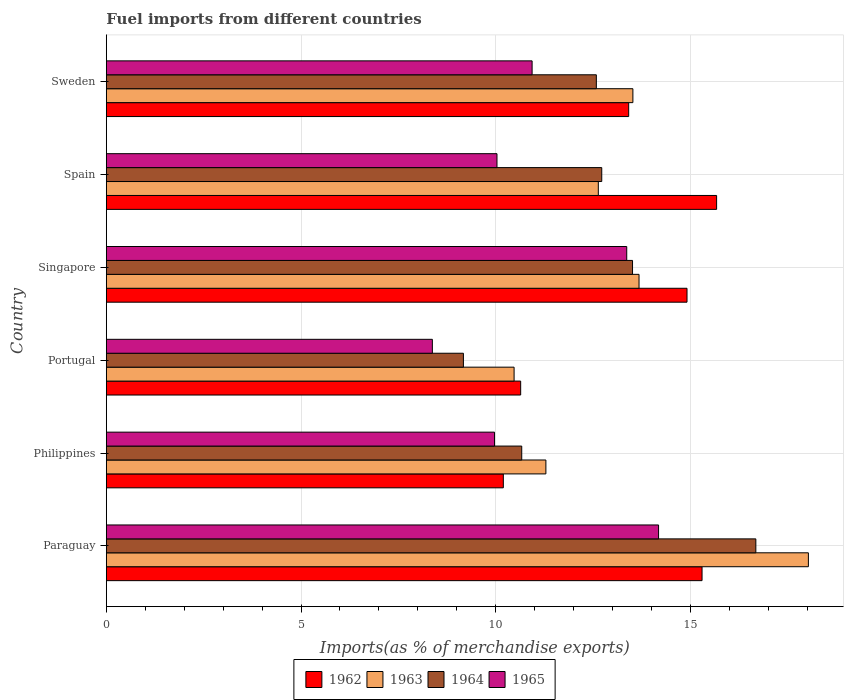How many different coloured bars are there?
Offer a very short reply. 4. How many bars are there on the 4th tick from the bottom?
Provide a succinct answer. 4. What is the label of the 3rd group of bars from the top?
Your answer should be very brief. Singapore. What is the percentage of imports to different countries in 1963 in Paraguay?
Your response must be concise. 18.03. Across all countries, what is the maximum percentage of imports to different countries in 1964?
Offer a terse response. 16.68. Across all countries, what is the minimum percentage of imports to different countries in 1965?
Provide a short and direct response. 8.37. In which country was the percentage of imports to different countries in 1963 maximum?
Provide a succinct answer. Paraguay. In which country was the percentage of imports to different countries in 1963 minimum?
Make the answer very short. Portugal. What is the total percentage of imports to different countries in 1963 in the graph?
Your response must be concise. 79.63. What is the difference between the percentage of imports to different countries in 1964 in Paraguay and that in Singapore?
Provide a short and direct response. 3.17. What is the difference between the percentage of imports to different countries in 1964 in Philippines and the percentage of imports to different countries in 1963 in Spain?
Keep it short and to the point. -1.97. What is the average percentage of imports to different countries in 1965 per country?
Ensure brevity in your answer.  11.14. What is the difference between the percentage of imports to different countries in 1965 and percentage of imports to different countries in 1962 in Sweden?
Make the answer very short. -2.48. In how many countries, is the percentage of imports to different countries in 1964 greater than 2 %?
Your answer should be compact. 6. What is the ratio of the percentage of imports to different countries in 1964 in Spain to that in Sweden?
Make the answer very short. 1.01. What is the difference between the highest and the second highest percentage of imports to different countries in 1964?
Ensure brevity in your answer.  3.17. What is the difference between the highest and the lowest percentage of imports to different countries in 1964?
Make the answer very short. 7.51. In how many countries, is the percentage of imports to different countries in 1963 greater than the average percentage of imports to different countries in 1963 taken over all countries?
Offer a terse response. 3. What does the 4th bar from the top in Sweden represents?
Keep it short and to the point. 1962. What does the 3rd bar from the bottom in Paraguay represents?
Your answer should be very brief. 1964. Are all the bars in the graph horizontal?
Your response must be concise. Yes. What is the difference between two consecutive major ticks on the X-axis?
Keep it short and to the point. 5. Are the values on the major ticks of X-axis written in scientific E-notation?
Provide a short and direct response. No. Does the graph contain grids?
Ensure brevity in your answer.  Yes. Where does the legend appear in the graph?
Offer a very short reply. Bottom center. How many legend labels are there?
Give a very brief answer. 4. How are the legend labels stacked?
Make the answer very short. Horizontal. What is the title of the graph?
Keep it short and to the point. Fuel imports from different countries. What is the label or title of the X-axis?
Your answer should be very brief. Imports(as % of merchandise exports). What is the Imports(as % of merchandise exports) in 1962 in Paraguay?
Offer a very short reply. 15.3. What is the Imports(as % of merchandise exports) of 1963 in Paraguay?
Your answer should be very brief. 18.03. What is the Imports(as % of merchandise exports) of 1964 in Paraguay?
Provide a succinct answer. 16.68. What is the Imports(as % of merchandise exports) in 1965 in Paraguay?
Provide a succinct answer. 14.18. What is the Imports(as % of merchandise exports) of 1962 in Philippines?
Offer a terse response. 10.2. What is the Imports(as % of merchandise exports) in 1963 in Philippines?
Make the answer very short. 11.29. What is the Imports(as % of merchandise exports) in 1964 in Philippines?
Your answer should be very brief. 10.67. What is the Imports(as % of merchandise exports) of 1965 in Philippines?
Ensure brevity in your answer.  9.97. What is the Imports(as % of merchandise exports) in 1962 in Portugal?
Provide a succinct answer. 10.64. What is the Imports(as % of merchandise exports) in 1963 in Portugal?
Your answer should be compact. 10.47. What is the Imports(as % of merchandise exports) in 1964 in Portugal?
Make the answer very short. 9.17. What is the Imports(as % of merchandise exports) in 1965 in Portugal?
Offer a terse response. 8.37. What is the Imports(as % of merchandise exports) of 1962 in Singapore?
Offer a terse response. 14.91. What is the Imports(as % of merchandise exports) in 1963 in Singapore?
Give a very brief answer. 13.68. What is the Imports(as % of merchandise exports) of 1964 in Singapore?
Make the answer very short. 13.51. What is the Imports(as % of merchandise exports) of 1965 in Singapore?
Make the answer very short. 13.37. What is the Imports(as % of merchandise exports) in 1962 in Spain?
Offer a very short reply. 15.67. What is the Imports(as % of merchandise exports) in 1963 in Spain?
Offer a terse response. 12.64. What is the Imports(as % of merchandise exports) of 1964 in Spain?
Offer a terse response. 12.72. What is the Imports(as % of merchandise exports) in 1965 in Spain?
Provide a short and direct response. 10.03. What is the Imports(as % of merchandise exports) of 1962 in Sweden?
Provide a short and direct response. 13.42. What is the Imports(as % of merchandise exports) in 1963 in Sweden?
Provide a short and direct response. 13.52. What is the Imports(as % of merchandise exports) in 1964 in Sweden?
Ensure brevity in your answer.  12.58. What is the Imports(as % of merchandise exports) of 1965 in Sweden?
Your answer should be very brief. 10.93. Across all countries, what is the maximum Imports(as % of merchandise exports) of 1962?
Give a very brief answer. 15.67. Across all countries, what is the maximum Imports(as % of merchandise exports) of 1963?
Your answer should be very brief. 18.03. Across all countries, what is the maximum Imports(as % of merchandise exports) in 1964?
Your answer should be compact. 16.68. Across all countries, what is the maximum Imports(as % of merchandise exports) in 1965?
Your answer should be very brief. 14.18. Across all countries, what is the minimum Imports(as % of merchandise exports) of 1962?
Offer a very short reply. 10.2. Across all countries, what is the minimum Imports(as % of merchandise exports) in 1963?
Keep it short and to the point. 10.47. Across all countries, what is the minimum Imports(as % of merchandise exports) of 1964?
Your response must be concise. 9.17. Across all countries, what is the minimum Imports(as % of merchandise exports) of 1965?
Give a very brief answer. 8.37. What is the total Imports(as % of merchandise exports) in 1962 in the graph?
Ensure brevity in your answer.  80.14. What is the total Imports(as % of merchandise exports) in 1963 in the graph?
Your answer should be very brief. 79.63. What is the total Imports(as % of merchandise exports) in 1964 in the graph?
Make the answer very short. 75.34. What is the total Imports(as % of merchandise exports) of 1965 in the graph?
Offer a terse response. 66.86. What is the difference between the Imports(as % of merchandise exports) of 1962 in Paraguay and that in Philippines?
Your answer should be compact. 5.1. What is the difference between the Imports(as % of merchandise exports) in 1963 in Paraguay and that in Philippines?
Keep it short and to the point. 6.74. What is the difference between the Imports(as % of merchandise exports) of 1964 in Paraguay and that in Philippines?
Make the answer very short. 6.01. What is the difference between the Imports(as % of merchandise exports) in 1965 in Paraguay and that in Philippines?
Your answer should be very brief. 4.21. What is the difference between the Imports(as % of merchandise exports) in 1962 in Paraguay and that in Portugal?
Offer a terse response. 4.66. What is the difference between the Imports(as % of merchandise exports) of 1963 in Paraguay and that in Portugal?
Make the answer very short. 7.56. What is the difference between the Imports(as % of merchandise exports) of 1964 in Paraguay and that in Portugal?
Ensure brevity in your answer.  7.51. What is the difference between the Imports(as % of merchandise exports) of 1965 in Paraguay and that in Portugal?
Your response must be concise. 5.81. What is the difference between the Imports(as % of merchandise exports) of 1962 in Paraguay and that in Singapore?
Give a very brief answer. 0.39. What is the difference between the Imports(as % of merchandise exports) in 1963 in Paraguay and that in Singapore?
Your answer should be very brief. 4.35. What is the difference between the Imports(as % of merchandise exports) of 1964 in Paraguay and that in Singapore?
Offer a terse response. 3.17. What is the difference between the Imports(as % of merchandise exports) of 1965 in Paraguay and that in Singapore?
Your answer should be very brief. 0.82. What is the difference between the Imports(as % of merchandise exports) in 1962 in Paraguay and that in Spain?
Ensure brevity in your answer.  -0.37. What is the difference between the Imports(as % of merchandise exports) in 1963 in Paraguay and that in Spain?
Offer a very short reply. 5.4. What is the difference between the Imports(as % of merchandise exports) in 1964 in Paraguay and that in Spain?
Provide a succinct answer. 3.96. What is the difference between the Imports(as % of merchandise exports) of 1965 in Paraguay and that in Spain?
Keep it short and to the point. 4.15. What is the difference between the Imports(as % of merchandise exports) in 1962 in Paraguay and that in Sweden?
Ensure brevity in your answer.  1.88. What is the difference between the Imports(as % of merchandise exports) in 1963 in Paraguay and that in Sweden?
Your response must be concise. 4.51. What is the difference between the Imports(as % of merchandise exports) of 1964 in Paraguay and that in Sweden?
Make the answer very short. 4.1. What is the difference between the Imports(as % of merchandise exports) in 1965 in Paraguay and that in Sweden?
Make the answer very short. 3.25. What is the difference between the Imports(as % of merchandise exports) in 1962 in Philippines and that in Portugal?
Your response must be concise. -0.45. What is the difference between the Imports(as % of merchandise exports) in 1963 in Philippines and that in Portugal?
Your answer should be compact. 0.82. What is the difference between the Imports(as % of merchandise exports) in 1964 in Philippines and that in Portugal?
Ensure brevity in your answer.  1.5. What is the difference between the Imports(as % of merchandise exports) of 1965 in Philippines and that in Portugal?
Offer a terse response. 1.6. What is the difference between the Imports(as % of merchandise exports) of 1962 in Philippines and that in Singapore?
Give a very brief answer. -4.72. What is the difference between the Imports(as % of merchandise exports) of 1963 in Philippines and that in Singapore?
Your answer should be very brief. -2.39. What is the difference between the Imports(as % of merchandise exports) of 1964 in Philippines and that in Singapore?
Provide a short and direct response. -2.85. What is the difference between the Imports(as % of merchandise exports) in 1965 in Philippines and that in Singapore?
Make the answer very short. -3.4. What is the difference between the Imports(as % of merchandise exports) in 1962 in Philippines and that in Spain?
Your answer should be compact. -5.48. What is the difference between the Imports(as % of merchandise exports) of 1963 in Philippines and that in Spain?
Provide a short and direct response. -1.35. What is the difference between the Imports(as % of merchandise exports) of 1964 in Philippines and that in Spain?
Ensure brevity in your answer.  -2.05. What is the difference between the Imports(as % of merchandise exports) of 1965 in Philippines and that in Spain?
Make the answer very short. -0.06. What is the difference between the Imports(as % of merchandise exports) in 1962 in Philippines and that in Sweden?
Your answer should be compact. -3.22. What is the difference between the Imports(as % of merchandise exports) of 1963 in Philippines and that in Sweden?
Give a very brief answer. -2.23. What is the difference between the Imports(as % of merchandise exports) of 1964 in Philippines and that in Sweden?
Provide a succinct answer. -1.92. What is the difference between the Imports(as % of merchandise exports) of 1965 in Philippines and that in Sweden?
Keep it short and to the point. -0.96. What is the difference between the Imports(as % of merchandise exports) of 1962 in Portugal and that in Singapore?
Keep it short and to the point. -4.27. What is the difference between the Imports(as % of merchandise exports) of 1963 in Portugal and that in Singapore?
Make the answer very short. -3.21. What is the difference between the Imports(as % of merchandise exports) of 1964 in Portugal and that in Singapore?
Your response must be concise. -4.34. What is the difference between the Imports(as % of merchandise exports) of 1965 in Portugal and that in Singapore?
Provide a succinct answer. -4.99. What is the difference between the Imports(as % of merchandise exports) in 1962 in Portugal and that in Spain?
Ensure brevity in your answer.  -5.03. What is the difference between the Imports(as % of merchandise exports) in 1963 in Portugal and that in Spain?
Offer a very short reply. -2.16. What is the difference between the Imports(as % of merchandise exports) of 1964 in Portugal and that in Spain?
Ensure brevity in your answer.  -3.55. What is the difference between the Imports(as % of merchandise exports) in 1965 in Portugal and that in Spain?
Provide a succinct answer. -1.66. What is the difference between the Imports(as % of merchandise exports) in 1962 in Portugal and that in Sweden?
Provide a short and direct response. -2.77. What is the difference between the Imports(as % of merchandise exports) in 1963 in Portugal and that in Sweden?
Ensure brevity in your answer.  -3.05. What is the difference between the Imports(as % of merchandise exports) of 1964 in Portugal and that in Sweden?
Provide a short and direct response. -3.41. What is the difference between the Imports(as % of merchandise exports) of 1965 in Portugal and that in Sweden?
Provide a succinct answer. -2.56. What is the difference between the Imports(as % of merchandise exports) of 1962 in Singapore and that in Spain?
Provide a short and direct response. -0.76. What is the difference between the Imports(as % of merchandise exports) in 1963 in Singapore and that in Spain?
Offer a terse response. 1.05. What is the difference between the Imports(as % of merchandise exports) in 1964 in Singapore and that in Spain?
Your answer should be compact. 0.79. What is the difference between the Imports(as % of merchandise exports) in 1965 in Singapore and that in Spain?
Your response must be concise. 3.33. What is the difference between the Imports(as % of merchandise exports) in 1962 in Singapore and that in Sweden?
Make the answer very short. 1.5. What is the difference between the Imports(as % of merchandise exports) of 1963 in Singapore and that in Sweden?
Your response must be concise. 0.16. What is the difference between the Imports(as % of merchandise exports) in 1964 in Singapore and that in Sweden?
Offer a very short reply. 0.93. What is the difference between the Imports(as % of merchandise exports) in 1965 in Singapore and that in Sweden?
Your answer should be compact. 2.43. What is the difference between the Imports(as % of merchandise exports) in 1962 in Spain and that in Sweden?
Ensure brevity in your answer.  2.26. What is the difference between the Imports(as % of merchandise exports) in 1963 in Spain and that in Sweden?
Your answer should be compact. -0.89. What is the difference between the Imports(as % of merchandise exports) of 1964 in Spain and that in Sweden?
Keep it short and to the point. 0.14. What is the difference between the Imports(as % of merchandise exports) in 1965 in Spain and that in Sweden?
Ensure brevity in your answer.  -0.9. What is the difference between the Imports(as % of merchandise exports) in 1962 in Paraguay and the Imports(as % of merchandise exports) in 1963 in Philippines?
Your answer should be compact. 4.01. What is the difference between the Imports(as % of merchandise exports) of 1962 in Paraguay and the Imports(as % of merchandise exports) of 1964 in Philippines?
Offer a terse response. 4.63. What is the difference between the Imports(as % of merchandise exports) of 1962 in Paraguay and the Imports(as % of merchandise exports) of 1965 in Philippines?
Ensure brevity in your answer.  5.33. What is the difference between the Imports(as % of merchandise exports) in 1963 in Paraguay and the Imports(as % of merchandise exports) in 1964 in Philippines?
Offer a terse response. 7.36. What is the difference between the Imports(as % of merchandise exports) of 1963 in Paraguay and the Imports(as % of merchandise exports) of 1965 in Philippines?
Offer a very short reply. 8.06. What is the difference between the Imports(as % of merchandise exports) in 1964 in Paraguay and the Imports(as % of merchandise exports) in 1965 in Philippines?
Give a very brief answer. 6.71. What is the difference between the Imports(as % of merchandise exports) of 1962 in Paraguay and the Imports(as % of merchandise exports) of 1963 in Portugal?
Offer a terse response. 4.83. What is the difference between the Imports(as % of merchandise exports) in 1962 in Paraguay and the Imports(as % of merchandise exports) in 1964 in Portugal?
Offer a very short reply. 6.13. What is the difference between the Imports(as % of merchandise exports) of 1962 in Paraguay and the Imports(as % of merchandise exports) of 1965 in Portugal?
Provide a succinct answer. 6.93. What is the difference between the Imports(as % of merchandise exports) in 1963 in Paraguay and the Imports(as % of merchandise exports) in 1964 in Portugal?
Give a very brief answer. 8.86. What is the difference between the Imports(as % of merchandise exports) in 1963 in Paraguay and the Imports(as % of merchandise exports) in 1965 in Portugal?
Keep it short and to the point. 9.66. What is the difference between the Imports(as % of merchandise exports) of 1964 in Paraguay and the Imports(as % of merchandise exports) of 1965 in Portugal?
Make the answer very short. 8.31. What is the difference between the Imports(as % of merchandise exports) in 1962 in Paraguay and the Imports(as % of merchandise exports) in 1963 in Singapore?
Provide a succinct answer. 1.62. What is the difference between the Imports(as % of merchandise exports) in 1962 in Paraguay and the Imports(as % of merchandise exports) in 1964 in Singapore?
Offer a terse response. 1.79. What is the difference between the Imports(as % of merchandise exports) in 1962 in Paraguay and the Imports(as % of merchandise exports) in 1965 in Singapore?
Provide a succinct answer. 1.93. What is the difference between the Imports(as % of merchandise exports) in 1963 in Paraguay and the Imports(as % of merchandise exports) in 1964 in Singapore?
Provide a succinct answer. 4.52. What is the difference between the Imports(as % of merchandise exports) of 1963 in Paraguay and the Imports(as % of merchandise exports) of 1965 in Singapore?
Your answer should be compact. 4.67. What is the difference between the Imports(as % of merchandise exports) of 1964 in Paraguay and the Imports(as % of merchandise exports) of 1965 in Singapore?
Make the answer very short. 3.32. What is the difference between the Imports(as % of merchandise exports) of 1962 in Paraguay and the Imports(as % of merchandise exports) of 1963 in Spain?
Keep it short and to the point. 2.66. What is the difference between the Imports(as % of merchandise exports) in 1962 in Paraguay and the Imports(as % of merchandise exports) in 1964 in Spain?
Give a very brief answer. 2.58. What is the difference between the Imports(as % of merchandise exports) of 1962 in Paraguay and the Imports(as % of merchandise exports) of 1965 in Spain?
Your response must be concise. 5.27. What is the difference between the Imports(as % of merchandise exports) in 1963 in Paraguay and the Imports(as % of merchandise exports) in 1964 in Spain?
Ensure brevity in your answer.  5.31. What is the difference between the Imports(as % of merchandise exports) in 1963 in Paraguay and the Imports(as % of merchandise exports) in 1965 in Spain?
Provide a succinct answer. 8. What is the difference between the Imports(as % of merchandise exports) of 1964 in Paraguay and the Imports(as % of merchandise exports) of 1965 in Spain?
Offer a terse response. 6.65. What is the difference between the Imports(as % of merchandise exports) of 1962 in Paraguay and the Imports(as % of merchandise exports) of 1963 in Sweden?
Ensure brevity in your answer.  1.78. What is the difference between the Imports(as % of merchandise exports) of 1962 in Paraguay and the Imports(as % of merchandise exports) of 1964 in Sweden?
Keep it short and to the point. 2.71. What is the difference between the Imports(as % of merchandise exports) of 1962 in Paraguay and the Imports(as % of merchandise exports) of 1965 in Sweden?
Your response must be concise. 4.36. What is the difference between the Imports(as % of merchandise exports) of 1963 in Paraguay and the Imports(as % of merchandise exports) of 1964 in Sweden?
Offer a very short reply. 5.45. What is the difference between the Imports(as % of merchandise exports) of 1963 in Paraguay and the Imports(as % of merchandise exports) of 1965 in Sweden?
Your answer should be very brief. 7.1. What is the difference between the Imports(as % of merchandise exports) in 1964 in Paraguay and the Imports(as % of merchandise exports) in 1965 in Sweden?
Provide a short and direct response. 5.75. What is the difference between the Imports(as % of merchandise exports) of 1962 in Philippines and the Imports(as % of merchandise exports) of 1963 in Portugal?
Offer a terse response. -0.28. What is the difference between the Imports(as % of merchandise exports) of 1962 in Philippines and the Imports(as % of merchandise exports) of 1964 in Portugal?
Your response must be concise. 1.03. What is the difference between the Imports(as % of merchandise exports) in 1962 in Philippines and the Imports(as % of merchandise exports) in 1965 in Portugal?
Give a very brief answer. 1.82. What is the difference between the Imports(as % of merchandise exports) of 1963 in Philippines and the Imports(as % of merchandise exports) of 1964 in Portugal?
Offer a very short reply. 2.12. What is the difference between the Imports(as % of merchandise exports) of 1963 in Philippines and the Imports(as % of merchandise exports) of 1965 in Portugal?
Provide a succinct answer. 2.92. What is the difference between the Imports(as % of merchandise exports) of 1964 in Philippines and the Imports(as % of merchandise exports) of 1965 in Portugal?
Provide a short and direct response. 2.3. What is the difference between the Imports(as % of merchandise exports) in 1962 in Philippines and the Imports(as % of merchandise exports) in 1963 in Singapore?
Provide a succinct answer. -3.49. What is the difference between the Imports(as % of merchandise exports) of 1962 in Philippines and the Imports(as % of merchandise exports) of 1964 in Singapore?
Keep it short and to the point. -3.32. What is the difference between the Imports(as % of merchandise exports) in 1962 in Philippines and the Imports(as % of merchandise exports) in 1965 in Singapore?
Provide a short and direct response. -3.17. What is the difference between the Imports(as % of merchandise exports) in 1963 in Philippines and the Imports(as % of merchandise exports) in 1964 in Singapore?
Give a very brief answer. -2.23. What is the difference between the Imports(as % of merchandise exports) of 1963 in Philippines and the Imports(as % of merchandise exports) of 1965 in Singapore?
Provide a short and direct response. -2.08. What is the difference between the Imports(as % of merchandise exports) in 1964 in Philippines and the Imports(as % of merchandise exports) in 1965 in Singapore?
Offer a very short reply. -2.7. What is the difference between the Imports(as % of merchandise exports) of 1962 in Philippines and the Imports(as % of merchandise exports) of 1963 in Spain?
Offer a terse response. -2.44. What is the difference between the Imports(as % of merchandise exports) in 1962 in Philippines and the Imports(as % of merchandise exports) in 1964 in Spain?
Keep it short and to the point. -2.53. What is the difference between the Imports(as % of merchandise exports) of 1962 in Philippines and the Imports(as % of merchandise exports) of 1965 in Spain?
Offer a very short reply. 0.16. What is the difference between the Imports(as % of merchandise exports) in 1963 in Philippines and the Imports(as % of merchandise exports) in 1964 in Spain?
Provide a succinct answer. -1.43. What is the difference between the Imports(as % of merchandise exports) in 1963 in Philippines and the Imports(as % of merchandise exports) in 1965 in Spain?
Provide a short and direct response. 1.26. What is the difference between the Imports(as % of merchandise exports) of 1964 in Philippines and the Imports(as % of merchandise exports) of 1965 in Spain?
Make the answer very short. 0.64. What is the difference between the Imports(as % of merchandise exports) in 1962 in Philippines and the Imports(as % of merchandise exports) in 1963 in Sweden?
Ensure brevity in your answer.  -3.33. What is the difference between the Imports(as % of merchandise exports) in 1962 in Philippines and the Imports(as % of merchandise exports) in 1964 in Sweden?
Offer a very short reply. -2.39. What is the difference between the Imports(as % of merchandise exports) of 1962 in Philippines and the Imports(as % of merchandise exports) of 1965 in Sweden?
Make the answer very short. -0.74. What is the difference between the Imports(as % of merchandise exports) of 1963 in Philippines and the Imports(as % of merchandise exports) of 1964 in Sweden?
Your answer should be compact. -1.3. What is the difference between the Imports(as % of merchandise exports) of 1963 in Philippines and the Imports(as % of merchandise exports) of 1965 in Sweden?
Keep it short and to the point. 0.35. What is the difference between the Imports(as % of merchandise exports) of 1964 in Philippines and the Imports(as % of merchandise exports) of 1965 in Sweden?
Offer a very short reply. -0.27. What is the difference between the Imports(as % of merchandise exports) of 1962 in Portugal and the Imports(as % of merchandise exports) of 1963 in Singapore?
Offer a terse response. -3.04. What is the difference between the Imports(as % of merchandise exports) in 1962 in Portugal and the Imports(as % of merchandise exports) in 1964 in Singapore?
Provide a succinct answer. -2.87. What is the difference between the Imports(as % of merchandise exports) in 1962 in Portugal and the Imports(as % of merchandise exports) in 1965 in Singapore?
Offer a terse response. -2.72. What is the difference between the Imports(as % of merchandise exports) of 1963 in Portugal and the Imports(as % of merchandise exports) of 1964 in Singapore?
Provide a succinct answer. -3.04. What is the difference between the Imports(as % of merchandise exports) in 1963 in Portugal and the Imports(as % of merchandise exports) in 1965 in Singapore?
Keep it short and to the point. -2.89. What is the difference between the Imports(as % of merchandise exports) of 1964 in Portugal and the Imports(as % of merchandise exports) of 1965 in Singapore?
Give a very brief answer. -4.19. What is the difference between the Imports(as % of merchandise exports) in 1962 in Portugal and the Imports(as % of merchandise exports) in 1963 in Spain?
Your response must be concise. -1.99. What is the difference between the Imports(as % of merchandise exports) in 1962 in Portugal and the Imports(as % of merchandise exports) in 1964 in Spain?
Offer a very short reply. -2.08. What is the difference between the Imports(as % of merchandise exports) in 1962 in Portugal and the Imports(as % of merchandise exports) in 1965 in Spain?
Provide a short and direct response. 0.61. What is the difference between the Imports(as % of merchandise exports) of 1963 in Portugal and the Imports(as % of merchandise exports) of 1964 in Spain?
Make the answer very short. -2.25. What is the difference between the Imports(as % of merchandise exports) of 1963 in Portugal and the Imports(as % of merchandise exports) of 1965 in Spain?
Provide a short and direct response. 0.44. What is the difference between the Imports(as % of merchandise exports) in 1964 in Portugal and the Imports(as % of merchandise exports) in 1965 in Spain?
Make the answer very short. -0.86. What is the difference between the Imports(as % of merchandise exports) of 1962 in Portugal and the Imports(as % of merchandise exports) of 1963 in Sweden?
Give a very brief answer. -2.88. What is the difference between the Imports(as % of merchandise exports) in 1962 in Portugal and the Imports(as % of merchandise exports) in 1964 in Sweden?
Ensure brevity in your answer.  -1.94. What is the difference between the Imports(as % of merchandise exports) in 1962 in Portugal and the Imports(as % of merchandise exports) in 1965 in Sweden?
Offer a terse response. -0.29. What is the difference between the Imports(as % of merchandise exports) of 1963 in Portugal and the Imports(as % of merchandise exports) of 1964 in Sweden?
Offer a very short reply. -2.11. What is the difference between the Imports(as % of merchandise exports) of 1963 in Portugal and the Imports(as % of merchandise exports) of 1965 in Sweden?
Provide a succinct answer. -0.46. What is the difference between the Imports(as % of merchandise exports) in 1964 in Portugal and the Imports(as % of merchandise exports) in 1965 in Sweden?
Provide a succinct answer. -1.76. What is the difference between the Imports(as % of merchandise exports) in 1962 in Singapore and the Imports(as % of merchandise exports) in 1963 in Spain?
Ensure brevity in your answer.  2.28. What is the difference between the Imports(as % of merchandise exports) of 1962 in Singapore and the Imports(as % of merchandise exports) of 1964 in Spain?
Your response must be concise. 2.19. What is the difference between the Imports(as % of merchandise exports) in 1962 in Singapore and the Imports(as % of merchandise exports) in 1965 in Spain?
Offer a very short reply. 4.88. What is the difference between the Imports(as % of merchandise exports) in 1963 in Singapore and the Imports(as % of merchandise exports) in 1964 in Spain?
Make the answer very short. 0.96. What is the difference between the Imports(as % of merchandise exports) in 1963 in Singapore and the Imports(as % of merchandise exports) in 1965 in Spain?
Give a very brief answer. 3.65. What is the difference between the Imports(as % of merchandise exports) in 1964 in Singapore and the Imports(as % of merchandise exports) in 1965 in Spain?
Give a very brief answer. 3.48. What is the difference between the Imports(as % of merchandise exports) of 1962 in Singapore and the Imports(as % of merchandise exports) of 1963 in Sweden?
Make the answer very short. 1.39. What is the difference between the Imports(as % of merchandise exports) in 1962 in Singapore and the Imports(as % of merchandise exports) in 1964 in Sweden?
Keep it short and to the point. 2.33. What is the difference between the Imports(as % of merchandise exports) of 1962 in Singapore and the Imports(as % of merchandise exports) of 1965 in Sweden?
Make the answer very short. 3.98. What is the difference between the Imports(as % of merchandise exports) in 1963 in Singapore and the Imports(as % of merchandise exports) in 1964 in Sweden?
Give a very brief answer. 1.1. What is the difference between the Imports(as % of merchandise exports) of 1963 in Singapore and the Imports(as % of merchandise exports) of 1965 in Sweden?
Your answer should be compact. 2.75. What is the difference between the Imports(as % of merchandise exports) in 1964 in Singapore and the Imports(as % of merchandise exports) in 1965 in Sweden?
Provide a short and direct response. 2.58. What is the difference between the Imports(as % of merchandise exports) of 1962 in Spain and the Imports(as % of merchandise exports) of 1963 in Sweden?
Your answer should be very brief. 2.15. What is the difference between the Imports(as % of merchandise exports) of 1962 in Spain and the Imports(as % of merchandise exports) of 1964 in Sweden?
Your answer should be compact. 3.09. What is the difference between the Imports(as % of merchandise exports) of 1962 in Spain and the Imports(as % of merchandise exports) of 1965 in Sweden?
Provide a short and direct response. 4.74. What is the difference between the Imports(as % of merchandise exports) in 1963 in Spain and the Imports(as % of merchandise exports) in 1964 in Sweden?
Ensure brevity in your answer.  0.05. What is the difference between the Imports(as % of merchandise exports) of 1963 in Spain and the Imports(as % of merchandise exports) of 1965 in Sweden?
Offer a terse response. 1.7. What is the difference between the Imports(as % of merchandise exports) in 1964 in Spain and the Imports(as % of merchandise exports) in 1965 in Sweden?
Your response must be concise. 1.79. What is the average Imports(as % of merchandise exports) in 1962 per country?
Offer a terse response. 13.36. What is the average Imports(as % of merchandise exports) of 1963 per country?
Keep it short and to the point. 13.27. What is the average Imports(as % of merchandise exports) in 1964 per country?
Your answer should be compact. 12.56. What is the average Imports(as % of merchandise exports) of 1965 per country?
Ensure brevity in your answer.  11.14. What is the difference between the Imports(as % of merchandise exports) in 1962 and Imports(as % of merchandise exports) in 1963 in Paraguay?
Your answer should be compact. -2.73. What is the difference between the Imports(as % of merchandise exports) in 1962 and Imports(as % of merchandise exports) in 1964 in Paraguay?
Make the answer very short. -1.38. What is the difference between the Imports(as % of merchandise exports) in 1962 and Imports(as % of merchandise exports) in 1965 in Paraguay?
Offer a terse response. 1.12. What is the difference between the Imports(as % of merchandise exports) in 1963 and Imports(as % of merchandise exports) in 1964 in Paraguay?
Offer a terse response. 1.35. What is the difference between the Imports(as % of merchandise exports) of 1963 and Imports(as % of merchandise exports) of 1965 in Paraguay?
Your response must be concise. 3.85. What is the difference between the Imports(as % of merchandise exports) of 1964 and Imports(as % of merchandise exports) of 1965 in Paraguay?
Make the answer very short. 2.5. What is the difference between the Imports(as % of merchandise exports) of 1962 and Imports(as % of merchandise exports) of 1963 in Philippines?
Provide a succinct answer. -1.09. What is the difference between the Imports(as % of merchandise exports) of 1962 and Imports(as % of merchandise exports) of 1964 in Philippines?
Your response must be concise. -0.47. What is the difference between the Imports(as % of merchandise exports) of 1962 and Imports(as % of merchandise exports) of 1965 in Philippines?
Make the answer very short. 0.23. What is the difference between the Imports(as % of merchandise exports) of 1963 and Imports(as % of merchandise exports) of 1964 in Philippines?
Your answer should be very brief. 0.62. What is the difference between the Imports(as % of merchandise exports) in 1963 and Imports(as % of merchandise exports) in 1965 in Philippines?
Provide a succinct answer. 1.32. What is the difference between the Imports(as % of merchandise exports) of 1964 and Imports(as % of merchandise exports) of 1965 in Philippines?
Your answer should be very brief. 0.7. What is the difference between the Imports(as % of merchandise exports) in 1962 and Imports(as % of merchandise exports) in 1963 in Portugal?
Ensure brevity in your answer.  0.17. What is the difference between the Imports(as % of merchandise exports) of 1962 and Imports(as % of merchandise exports) of 1964 in Portugal?
Your answer should be very brief. 1.47. What is the difference between the Imports(as % of merchandise exports) of 1962 and Imports(as % of merchandise exports) of 1965 in Portugal?
Provide a short and direct response. 2.27. What is the difference between the Imports(as % of merchandise exports) in 1963 and Imports(as % of merchandise exports) in 1964 in Portugal?
Provide a succinct answer. 1.3. What is the difference between the Imports(as % of merchandise exports) of 1963 and Imports(as % of merchandise exports) of 1965 in Portugal?
Keep it short and to the point. 2.1. What is the difference between the Imports(as % of merchandise exports) of 1964 and Imports(as % of merchandise exports) of 1965 in Portugal?
Provide a succinct answer. 0.8. What is the difference between the Imports(as % of merchandise exports) in 1962 and Imports(as % of merchandise exports) in 1963 in Singapore?
Your answer should be compact. 1.23. What is the difference between the Imports(as % of merchandise exports) in 1962 and Imports(as % of merchandise exports) in 1964 in Singapore?
Your answer should be very brief. 1.4. What is the difference between the Imports(as % of merchandise exports) of 1962 and Imports(as % of merchandise exports) of 1965 in Singapore?
Provide a short and direct response. 1.55. What is the difference between the Imports(as % of merchandise exports) in 1963 and Imports(as % of merchandise exports) in 1964 in Singapore?
Ensure brevity in your answer.  0.17. What is the difference between the Imports(as % of merchandise exports) in 1963 and Imports(as % of merchandise exports) in 1965 in Singapore?
Offer a very short reply. 0.32. What is the difference between the Imports(as % of merchandise exports) of 1964 and Imports(as % of merchandise exports) of 1965 in Singapore?
Give a very brief answer. 0.15. What is the difference between the Imports(as % of merchandise exports) in 1962 and Imports(as % of merchandise exports) in 1963 in Spain?
Make the answer very short. 3.04. What is the difference between the Imports(as % of merchandise exports) of 1962 and Imports(as % of merchandise exports) of 1964 in Spain?
Your answer should be very brief. 2.95. What is the difference between the Imports(as % of merchandise exports) of 1962 and Imports(as % of merchandise exports) of 1965 in Spain?
Provide a succinct answer. 5.64. What is the difference between the Imports(as % of merchandise exports) in 1963 and Imports(as % of merchandise exports) in 1964 in Spain?
Offer a terse response. -0.09. What is the difference between the Imports(as % of merchandise exports) of 1963 and Imports(as % of merchandise exports) of 1965 in Spain?
Offer a very short reply. 2.6. What is the difference between the Imports(as % of merchandise exports) in 1964 and Imports(as % of merchandise exports) in 1965 in Spain?
Provide a short and direct response. 2.69. What is the difference between the Imports(as % of merchandise exports) of 1962 and Imports(as % of merchandise exports) of 1963 in Sweden?
Give a very brief answer. -0.11. What is the difference between the Imports(as % of merchandise exports) in 1962 and Imports(as % of merchandise exports) in 1964 in Sweden?
Your answer should be very brief. 0.83. What is the difference between the Imports(as % of merchandise exports) of 1962 and Imports(as % of merchandise exports) of 1965 in Sweden?
Keep it short and to the point. 2.48. What is the difference between the Imports(as % of merchandise exports) of 1963 and Imports(as % of merchandise exports) of 1964 in Sweden?
Offer a terse response. 0.94. What is the difference between the Imports(as % of merchandise exports) in 1963 and Imports(as % of merchandise exports) in 1965 in Sweden?
Your response must be concise. 2.59. What is the difference between the Imports(as % of merchandise exports) of 1964 and Imports(as % of merchandise exports) of 1965 in Sweden?
Make the answer very short. 1.65. What is the ratio of the Imports(as % of merchandise exports) of 1962 in Paraguay to that in Philippines?
Your response must be concise. 1.5. What is the ratio of the Imports(as % of merchandise exports) in 1963 in Paraguay to that in Philippines?
Provide a short and direct response. 1.6. What is the ratio of the Imports(as % of merchandise exports) in 1964 in Paraguay to that in Philippines?
Your response must be concise. 1.56. What is the ratio of the Imports(as % of merchandise exports) of 1965 in Paraguay to that in Philippines?
Offer a terse response. 1.42. What is the ratio of the Imports(as % of merchandise exports) in 1962 in Paraguay to that in Portugal?
Provide a succinct answer. 1.44. What is the ratio of the Imports(as % of merchandise exports) of 1963 in Paraguay to that in Portugal?
Ensure brevity in your answer.  1.72. What is the ratio of the Imports(as % of merchandise exports) in 1964 in Paraguay to that in Portugal?
Keep it short and to the point. 1.82. What is the ratio of the Imports(as % of merchandise exports) of 1965 in Paraguay to that in Portugal?
Ensure brevity in your answer.  1.69. What is the ratio of the Imports(as % of merchandise exports) of 1962 in Paraguay to that in Singapore?
Provide a short and direct response. 1.03. What is the ratio of the Imports(as % of merchandise exports) in 1963 in Paraguay to that in Singapore?
Offer a terse response. 1.32. What is the ratio of the Imports(as % of merchandise exports) in 1964 in Paraguay to that in Singapore?
Give a very brief answer. 1.23. What is the ratio of the Imports(as % of merchandise exports) in 1965 in Paraguay to that in Singapore?
Your response must be concise. 1.06. What is the ratio of the Imports(as % of merchandise exports) of 1962 in Paraguay to that in Spain?
Make the answer very short. 0.98. What is the ratio of the Imports(as % of merchandise exports) of 1963 in Paraguay to that in Spain?
Your answer should be compact. 1.43. What is the ratio of the Imports(as % of merchandise exports) in 1964 in Paraguay to that in Spain?
Keep it short and to the point. 1.31. What is the ratio of the Imports(as % of merchandise exports) of 1965 in Paraguay to that in Spain?
Your answer should be very brief. 1.41. What is the ratio of the Imports(as % of merchandise exports) of 1962 in Paraguay to that in Sweden?
Make the answer very short. 1.14. What is the ratio of the Imports(as % of merchandise exports) in 1963 in Paraguay to that in Sweden?
Ensure brevity in your answer.  1.33. What is the ratio of the Imports(as % of merchandise exports) of 1964 in Paraguay to that in Sweden?
Provide a short and direct response. 1.33. What is the ratio of the Imports(as % of merchandise exports) of 1965 in Paraguay to that in Sweden?
Offer a terse response. 1.3. What is the ratio of the Imports(as % of merchandise exports) in 1962 in Philippines to that in Portugal?
Offer a very short reply. 0.96. What is the ratio of the Imports(as % of merchandise exports) of 1963 in Philippines to that in Portugal?
Provide a succinct answer. 1.08. What is the ratio of the Imports(as % of merchandise exports) of 1964 in Philippines to that in Portugal?
Offer a very short reply. 1.16. What is the ratio of the Imports(as % of merchandise exports) of 1965 in Philippines to that in Portugal?
Your answer should be compact. 1.19. What is the ratio of the Imports(as % of merchandise exports) in 1962 in Philippines to that in Singapore?
Your answer should be compact. 0.68. What is the ratio of the Imports(as % of merchandise exports) of 1963 in Philippines to that in Singapore?
Ensure brevity in your answer.  0.83. What is the ratio of the Imports(as % of merchandise exports) in 1964 in Philippines to that in Singapore?
Offer a terse response. 0.79. What is the ratio of the Imports(as % of merchandise exports) of 1965 in Philippines to that in Singapore?
Keep it short and to the point. 0.75. What is the ratio of the Imports(as % of merchandise exports) of 1962 in Philippines to that in Spain?
Give a very brief answer. 0.65. What is the ratio of the Imports(as % of merchandise exports) of 1963 in Philippines to that in Spain?
Offer a terse response. 0.89. What is the ratio of the Imports(as % of merchandise exports) in 1964 in Philippines to that in Spain?
Your answer should be compact. 0.84. What is the ratio of the Imports(as % of merchandise exports) in 1965 in Philippines to that in Spain?
Ensure brevity in your answer.  0.99. What is the ratio of the Imports(as % of merchandise exports) of 1962 in Philippines to that in Sweden?
Provide a succinct answer. 0.76. What is the ratio of the Imports(as % of merchandise exports) in 1963 in Philippines to that in Sweden?
Provide a short and direct response. 0.83. What is the ratio of the Imports(as % of merchandise exports) in 1964 in Philippines to that in Sweden?
Offer a terse response. 0.85. What is the ratio of the Imports(as % of merchandise exports) of 1965 in Philippines to that in Sweden?
Your answer should be very brief. 0.91. What is the ratio of the Imports(as % of merchandise exports) of 1962 in Portugal to that in Singapore?
Make the answer very short. 0.71. What is the ratio of the Imports(as % of merchandise exports) of 1963 in Portugal to that in Singapore?
Provide a succinct answer. 0.77. What is the ratio of the Imports(as % of merchandise exports) in 1964 in Portugal to that in Singapore?
Offer a terse response. 0.68. What is the ratio of the Imports(as % of merchandise exports) in 1965 in Portugal to that in Singapore?
Give a very brief answer. 0.63. What is the ratio of the Imports(as % of merchandise exports) of 1962 in Portugal to that in Spain?
Give a very brief answer. 0.68. What is the ratio of the Imports(as % of merchandise exports) of 1963 in Portugal to that in Spain?
Provide a short and direct response. 0.83. What is the ratio of the Imports(as % of merchandise exports) in 1964 in Portugal to that in Spain?
Offer a terse response. 0.72. What is the ratio of the Imports(as % of merchandise exports) of 1965 in Portugal to that in Spain?
Keep it short and to the point. 0.83. What is the ratio of the Imports(as % of merchandise exports) in 1962 in Portugal to that in Sweden?
Offer a very short reply. 0.79. What is the ratio of the Imports(as % of merchandise exports) of 1963 in Portugal to that in Sweden?
Provide a short and direct response. 0.77. What is the ratio of the Imports(as % of merchandise exports) of 1964 in Portugal to that in Sweden?
Your answer should be compact. 0.73. What is the ratio of the Imports(as % of merchandise exports) of 1965 in Portugal to that in Sweden?
Your answer should be compact. 0.77. What is the ratio of the Imports(as % of merchandise exports) of 1962 in Singapore to that in Spain?
Offer a terse response. 0.95. What is the ratio of the Imports(as % of merchandise exports) of 1963 in Singapore to that in Spain?
Your response must be concise. 1.08. What is the ratio of the Imports(as % of merchandise exports) in 1964 in Singapore to that in Spain?
Your response must be concise. 1.06. What is the ratio of the Imports(as % of merchandise exports) in 1965 in Singapore to that in Spain?
Offer a terse response. 1.33. What is the ratio of the Imports(as % of merchandise exports) of 1962 in Singapore to that in Sweden?
Your answer should be compact. 1.11. What is the ratio of the Imports(as % of merchandise exports) of 1963 in Singapore to that in Sweden?
Offer a very short reply. 1.01. What is the ratio of the Imports(as % of merchandise exports) in 1964 in Singapore to that in Sweden?
Your answer should be compact. 1.07. What is the ratio of the Imports(as % of merchandise exports) in 1965 in Singapore to that in Sweden?
Give a very brief answer. 1.22. What is the ratio of the Imports(as % of merchandise exports) in 1962 in Spain to that in Sweden?
Offer a very short reply. 1.17. What is the ratio of the Imports(as % of merchandise exports) in 1963 in Spain to that in Sweden?
Your answer should be very brief. 0.93. What is the ratio of the Imports(as % of merchandise exports) of 1964 in Spain to that in Sweden?
Offer a very short reply. 1.01. What is the ratio of the Imports(as % of merchandise exports) in 1965 in Spain to that in Sweden?
Provide a short and direct response. 0.92. What is the difference between the highest and the second highest Imports(as % of merchandise exports) in 1962?
Your response must be concise. 0.37. What is the difference between the highest and the second highest Imports(as % of merchandise exports) of 1963?
Provide a short and direct response. 4.35. What is the difference between the highest and the second highest Imports(as % of merchandise exports) of 1964?
Your response must be concise. 3.17. What is the difference between the highest and the second highest Imports(as % of merchandise exports) of 1965?
Offer a terse response. 0.82. What is the difference between the highest and the lowest Imports(as % of merchandise exports) in 1962?
Make the answer very short. 5.48. What is the difference between the highest and the lowest Imports(as % of merchandise exports) in 1963?
Offer a terse response. 7.56. What is the difference between the highest and the lowest Imports(as % of merchandise exports) in 1964?
Offer a terse response. 7.51. What is the difference between the highest and the lowest Imports(as % of merchandise exports) in 1965?
Provide a succinct answer. 5.81. 